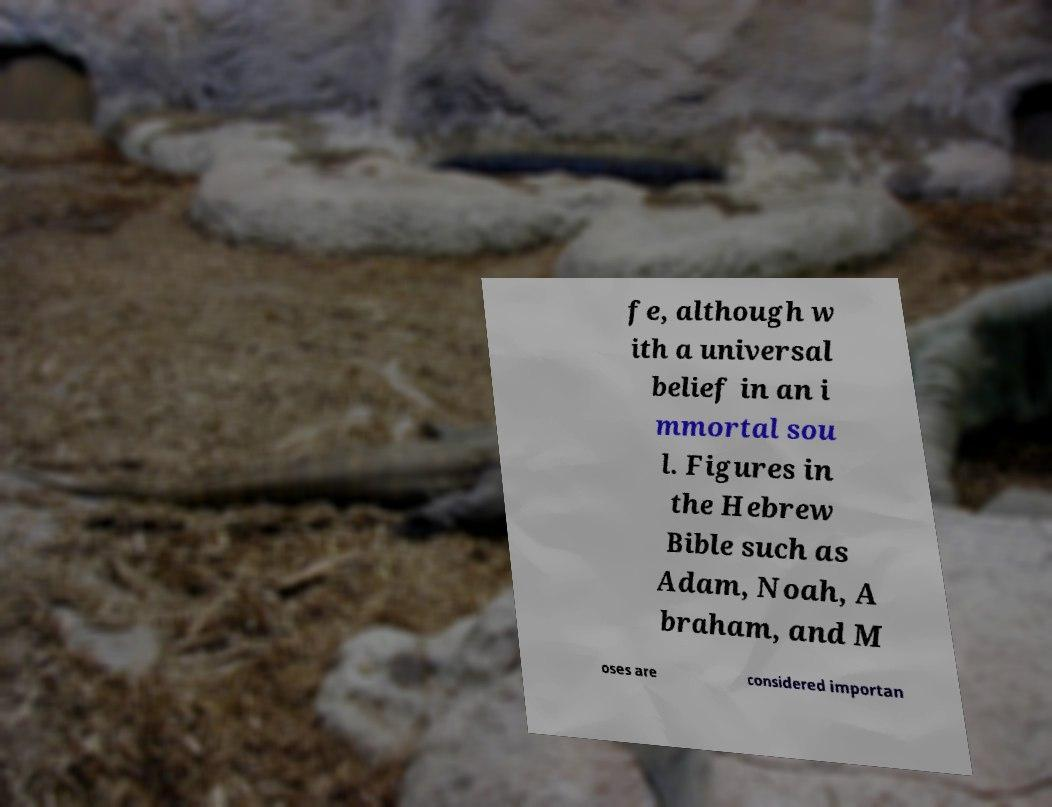Can you accurately transcribe the text from the provided image for me? fe, although w ith a universal belief in an i mmortal sou l. Figures in the Hebrew Bible such as Adam, Noah, A braham, and M oses are considered importan 